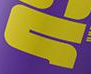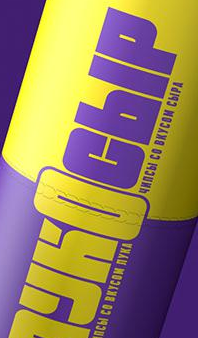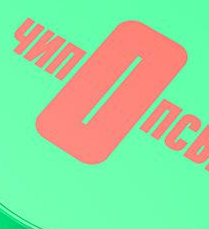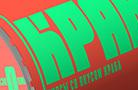Read the text content from these images in order, separated by a semicolon. #; YKOCbIP; nOnC; KPA 